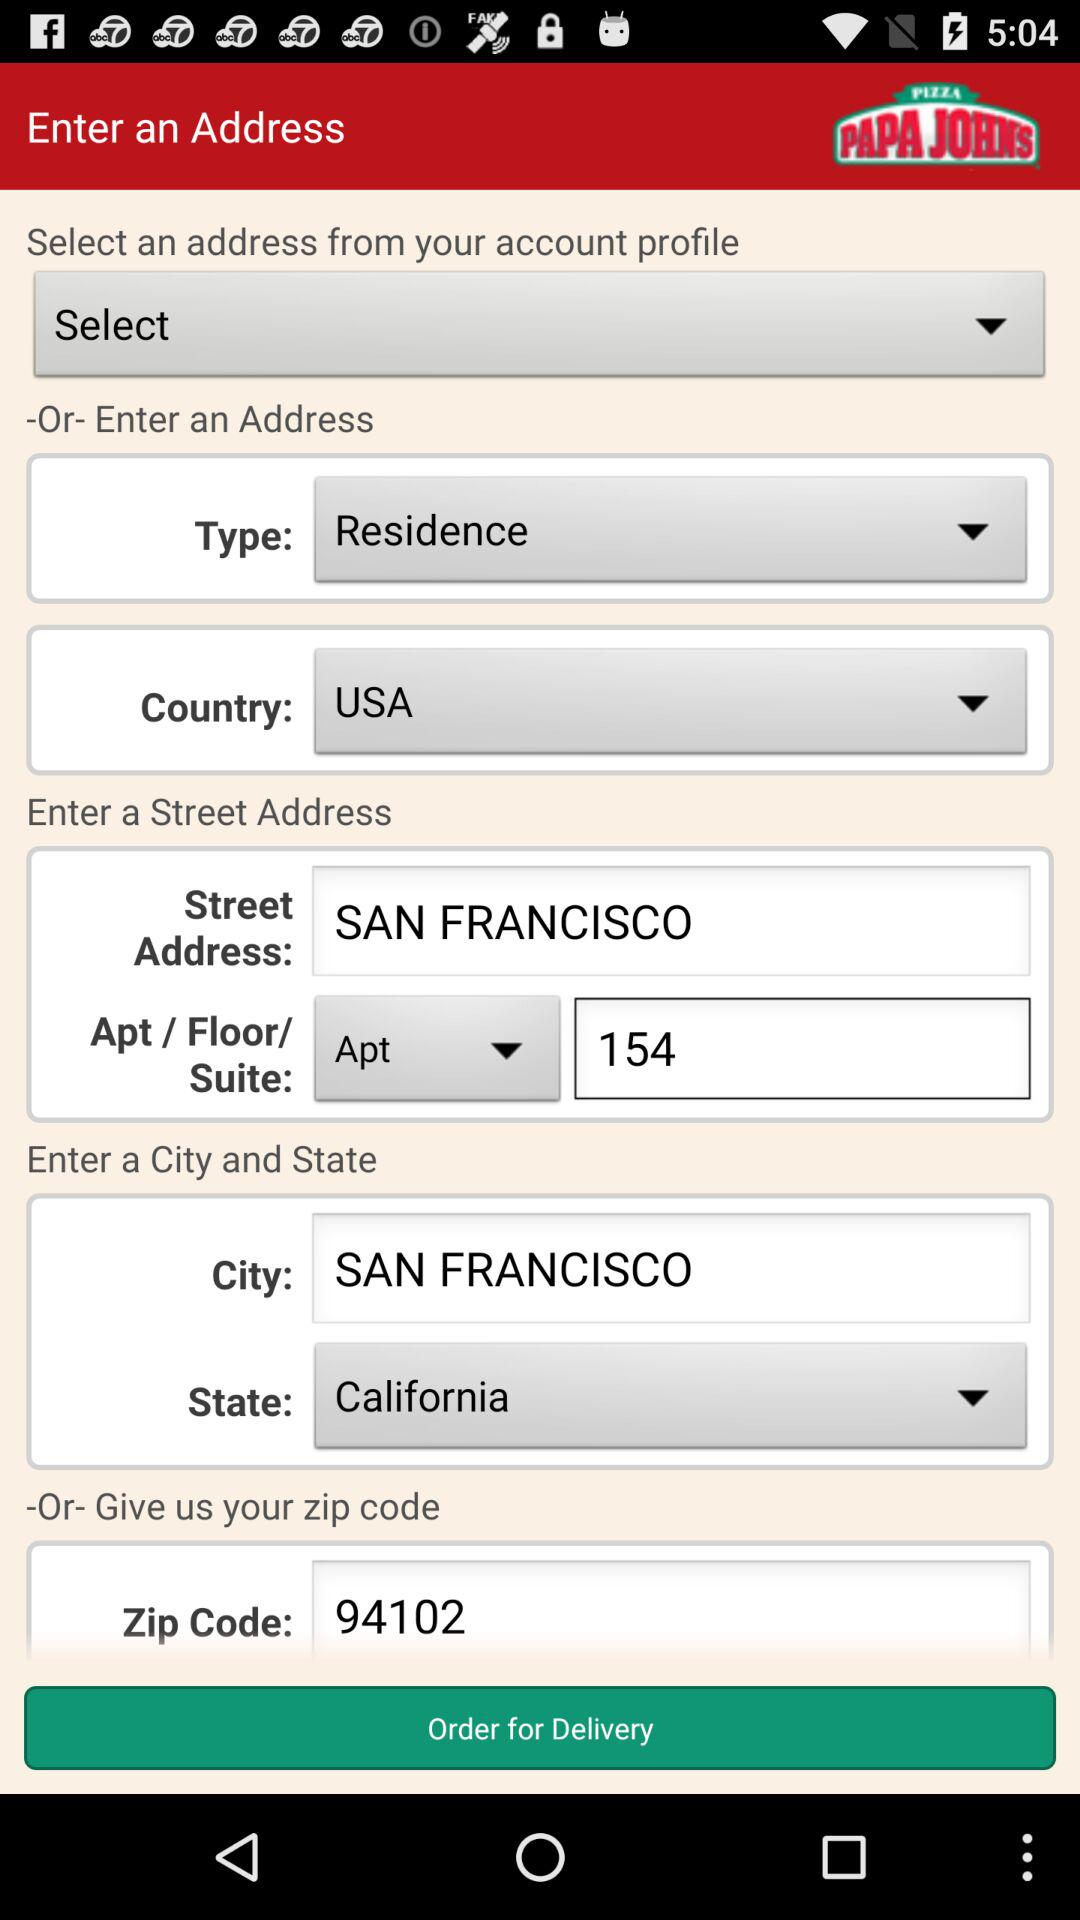Which is the selected country? The selected country is the USA. 